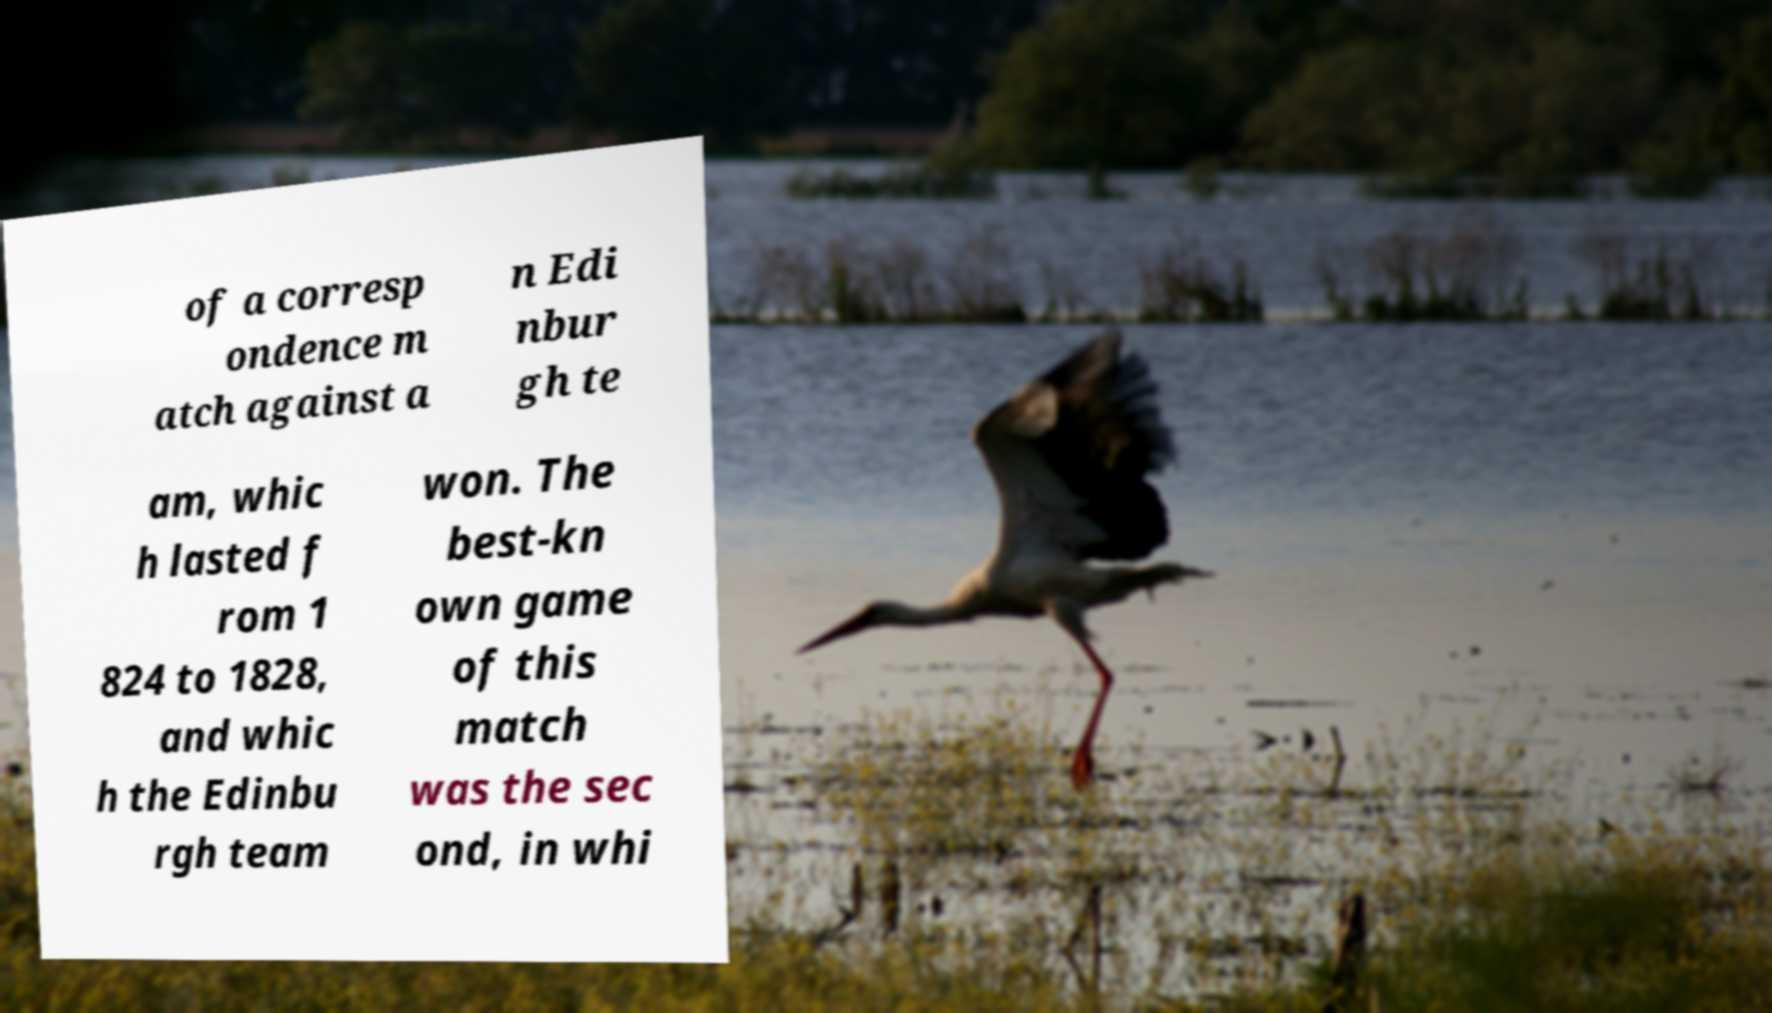Can you accurately transcribe the text from the provided image for me? of a corresp ondence m atch against a n Edi nbur gh te am, whic h lasted f rom 1 824 to 1828, and whic h the Edinbu rgh team won. The best-kn own game of this match was the sec ond, in whi 